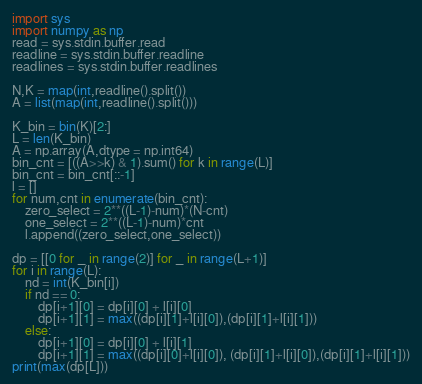Convert code to text. <code><loc_0><loc_0><loc_500><loc_500><_Python_>import sys 
import numpy as np
read = sys.stdin.buffer.read
readline = sys.stdin.buffer.readline
readlines = sys.stdin.buffer.readlines

N,K = map(int,readline().split())
A = list(map(int,readline().split()))

K_bin = bin(K)[2:]
L = len(K_bin)
A = np.array(A,dtype = np.int64)
bin_cnt = [((A>>k) & 1).sum() for k in range(L)]
bin_cnt = bin_cnt[::-1]
l = []
for num,cnt in enumerate(bin_cnt):
    zero_select = 2**((L-1)-num)*(N-cnt)
    one_select = 2**((L-1)-num)*cnt
    l.append((zero_select,one_select))

dp = [[0 for _ in range(2)] for _ in range(L+1)]
for i in range(L):
    nd = int(K_bin[i])
    if nd == 0:
        dp[i+1][0] = dp[i][0] + l[i][0]
        dp[i+1][1] = max((dp[i][1]+l[i][0]),(dp[i][1]+l[i][1]))
    else:
        dp[i+1][0] = dp[i][0] + l[i][1]
        dp[i+1][1] = max((dp[i][0]+l[i][0]), (dp[i][1]+l[i][0]),(dp[i][1]+l[i][1]))
print(max(dp[L]))   </code> 